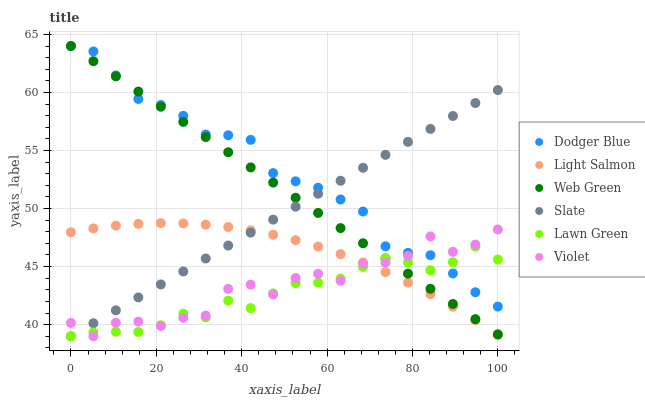Does Lawn Green have the minimum area under the curve?
Answer yes or no. Yes. Does Dodger Blue have the maximum area under the curve?
Answer yes or no. Yes. Does Light Salmon have the minimum area under the curve?
Answer yes or no. No. Does Light Salmon have the maximum area under the curve?
Answer yes or no. No. Is Web Green the smoothest?
Answer yes or no. Yes. Is Violet the roughest?
Answer yes or no. Yes. Is Light Salmon the smoothest?
Answer yes or no. No. Is Light Salmon the roughest?
Answer yes or no. No. Does Lawn Green have the lowest value?
Answer yes or no. Yes. Does Light Salmon have the lowest value?
Answer yes or no. No. Does Dodger Blue have the highest value?
Answer yes or no. Yes. Does Light Salmon have the highest value?
Answer yes or no. No. Is Light Salmon less than Web Green?
Answer yes or no. Yes. Is Dodger Blue greater than Light Salmon?
Answer yes or no. Yes. Does Violet intersect Lawn Green?
Answer yes or no. Yes. Is Violet less than Lawn Green?
Answer yes or no. No. Is Violet greater than Lawn Green?
Answer yes or no. No. Does Light Salmon intersect Web Green?
Answer yes or no. No. 